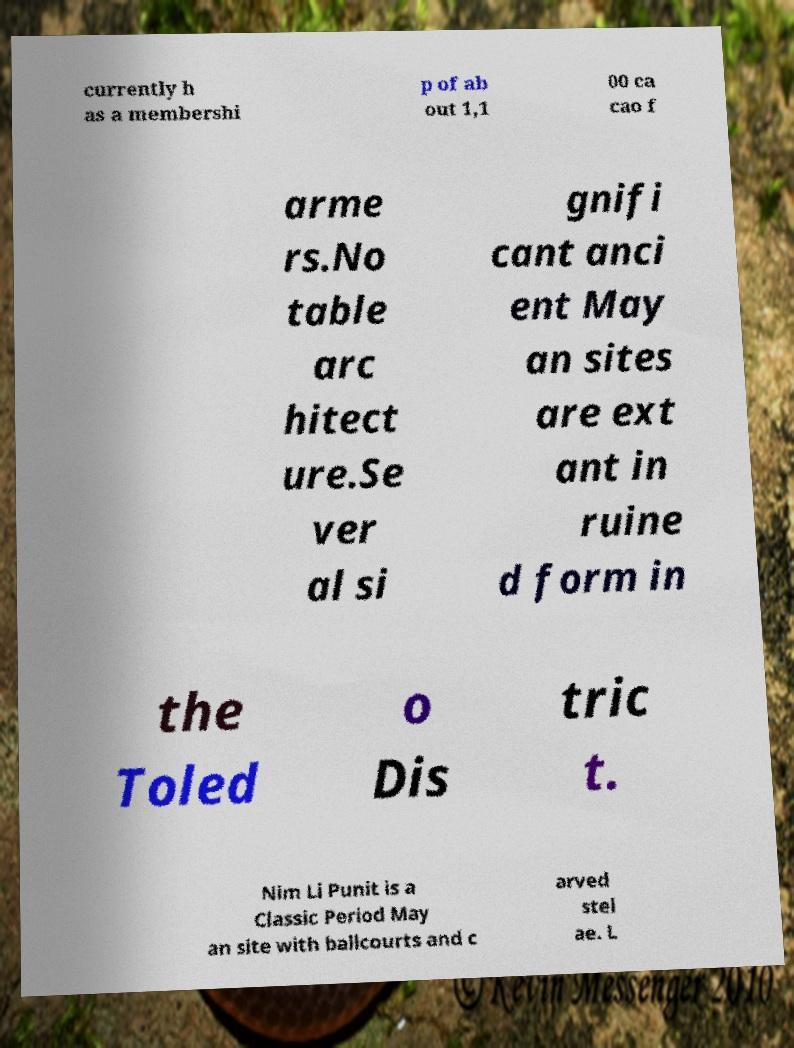Could you assist in decoding the text presented in this image and type it out clearly? currently h as a membershi p of ab out 1,1 00 ca cao f arme rs.No table arc hitect ure.Se ver al si gnifi cant anci ent May an sites are ext ant in ruine d form in the Toled o Dis tric t. Nim Li Punit is a Classic Period May an site with ballcourts and c arved stel ae. L 